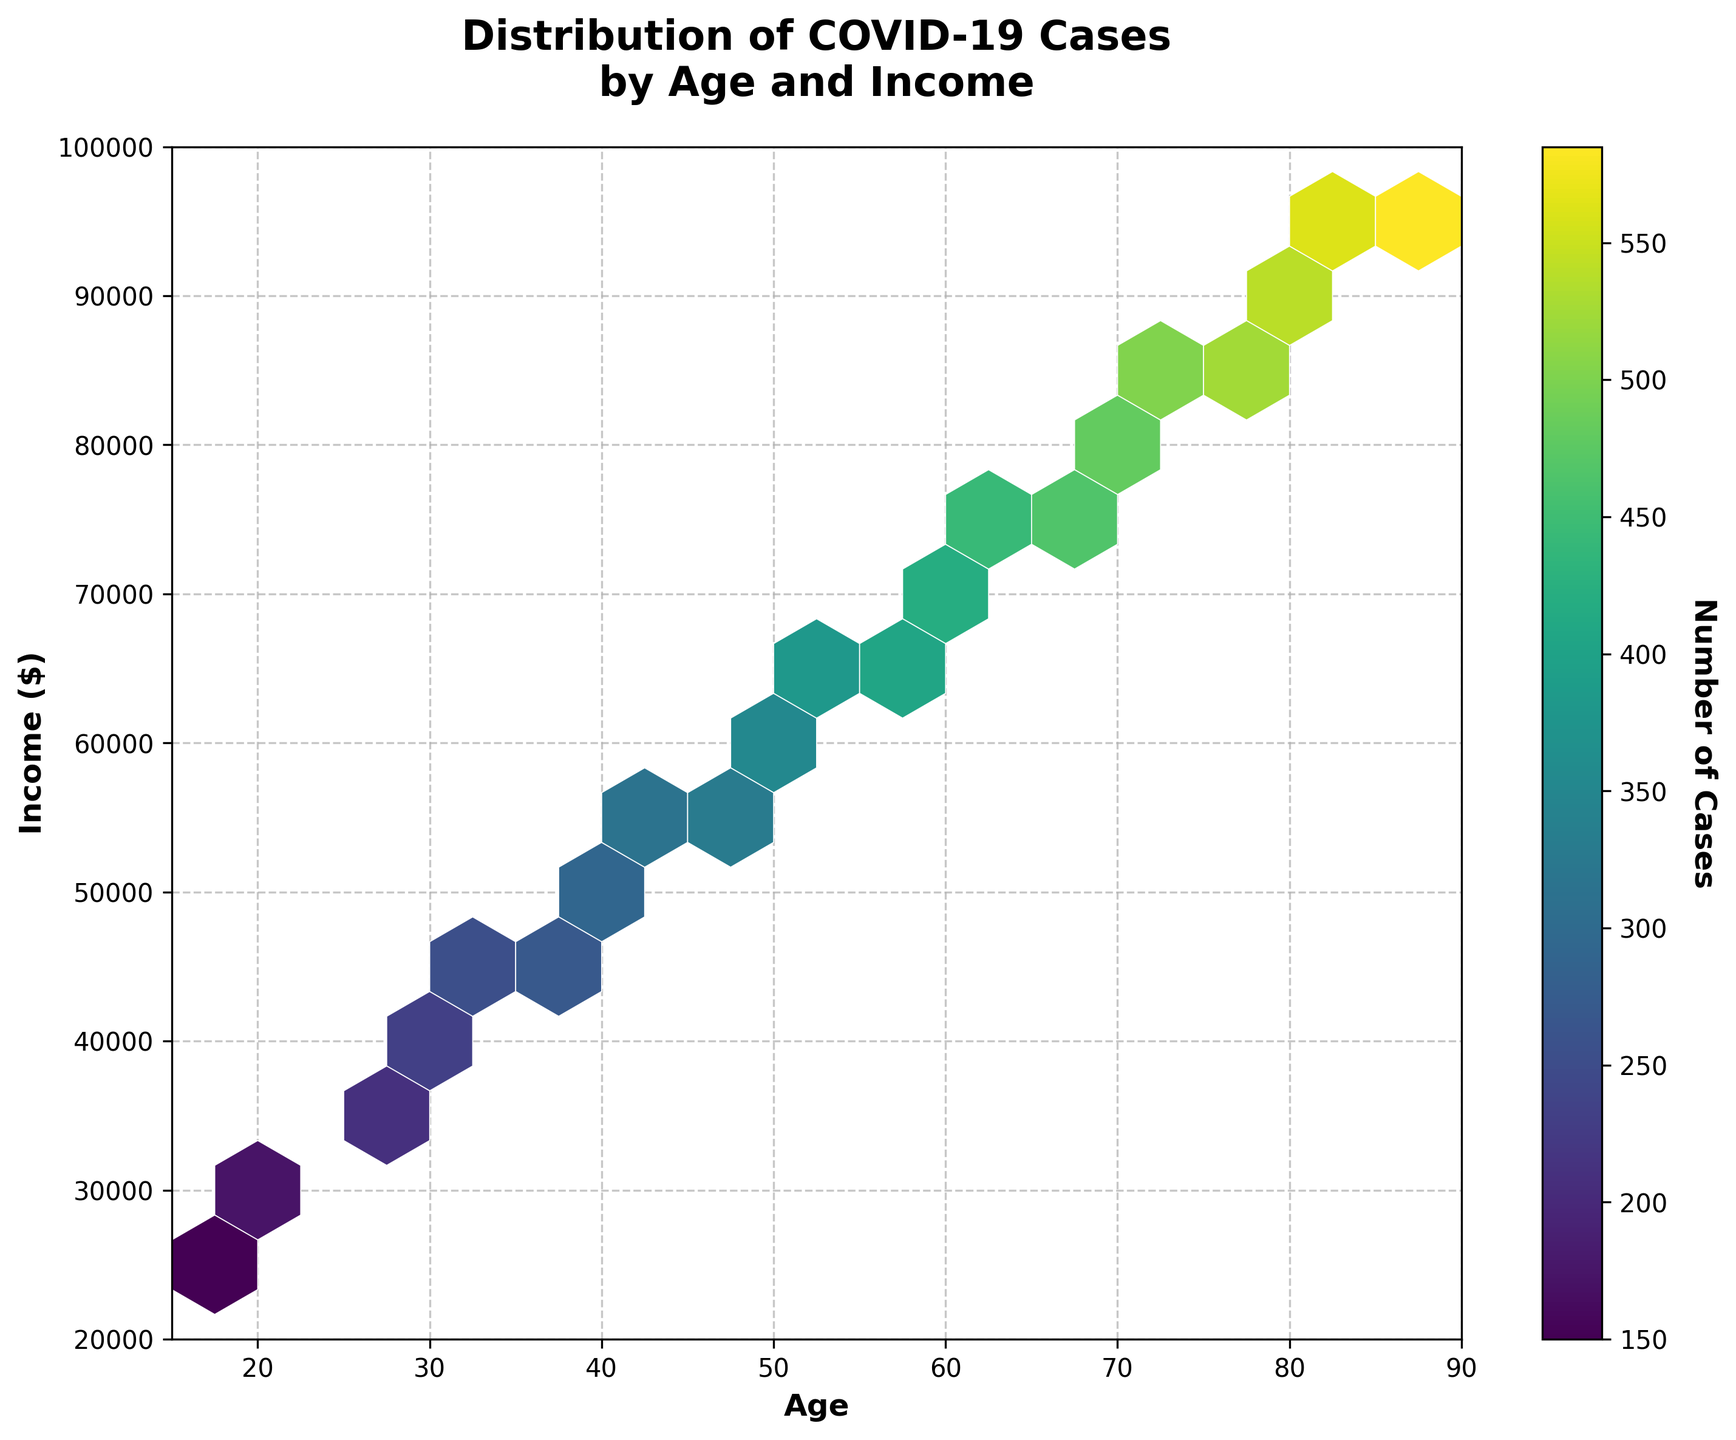What is the title of the plot? The title of the plot is displayed at the top of the figure, which reads "Distribution of COVID-19 Cases by Age and Income".
Answer: Distribution of COVID-19 Cases by Age and Income What do the x-axis and y-axis represent? The x-axis and y-axis labels are provided on the figure. The x-axis represents "Age", and the y-axis represents "Income ($)".
Answer: Age and Income ($) What color scheme is used in the hexbin plot? The color scheme or colormap used in the hexbin plot can be seen in the figure; it is a gradient from dark to light colors representing varying intensity, with a purple to yellow color scale.
Answer: Viridis Which age group seems to have the highest number of cases? By observing the color intensity on the hexbin plot, the darkest hexagon near the center corresponds to the age around 40-45. Hence, this age group has the highest number of cases.
Answer: 40-45 How does the number of cases vary with income levels for ages between 20 and 30? For ages between 20 and 30, observe the color of hexagons within this range on the x-axis and compare them across different y-axis values for income. The hexbin plot shows medium intensity colors indicating a moderate number of cases across different income levels for this age range.
Answer: Moderate across various income levels Is there a significant concentration of COVID-19 cases in any specific age and income range? The hexbin plot colors indicate density. The most intense (darkest) hexagons represent the highest concentrations. The most intense color is around the age range of 40-45 and income range of $50,000 to $60,000.
Answer: Age 40-45 and income $50,000-$60,000 For income levels above $80,000, which age groups have the maximum cases? The hexbin plot's colors above the $80,000 income level should be observed. The highest density (darkest colors) is observed around age groups of 75-85.
Answer: 75-85 How does the distribution of cases change for people aged over 70? Looking at the hexbin plot for the age values over 70 on the x-axis, the colors range from medium to high intensity, suggesting that the number of cases is generally distributed and slightly increasing with income.
Answer: Generally distributed to slightly increasing Compare the number of cases for the age group 30-35 with an income level of $40,000-50,000 to the age group 50-55 with the same income level. By observing the hexagonal colors for the specific age and income range, note the intensity difference. The intensity for the age group 30-35 in the $40,000-50,000 range is lower than that for the age group 50-55 in the same income range.
Answer: Age group 50-55 has more cases What does the color bar represent? The color bar placed next to the hexbin plot represents the gradient of case numbers, with labels indicating "Number of Cases". Darker colors indicate more cases, while lighter colors indicate fewer cases.
Answer: Number of Cases 